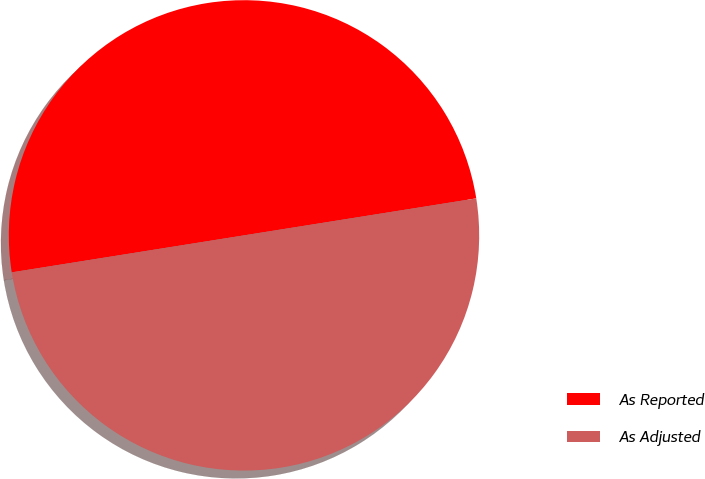Convert chart to OTSL. <chart><loc_0><loc_0><loc_500><loc_500><pie_chart><fcel>As Reported<fcel>As Adjusted<nl><fcel>50.0%<fcel>50.0%<nl></chart> 